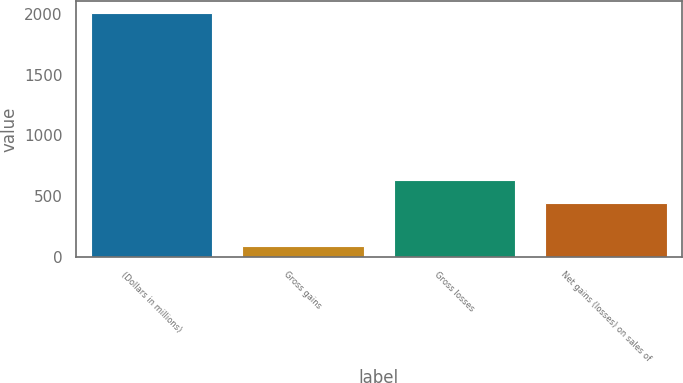Convert chart. <chart><loc_0><loc_0><loc_500><loc_500><bar_chart><fcel>(Dollars in millions)<fcel>Gross gains<fcel>Gross losses<fcel>Net gains (losses) on sales of<nl><fcel>2006<fcel>87<fcel>634.9<fcel>443<nl></chart> 